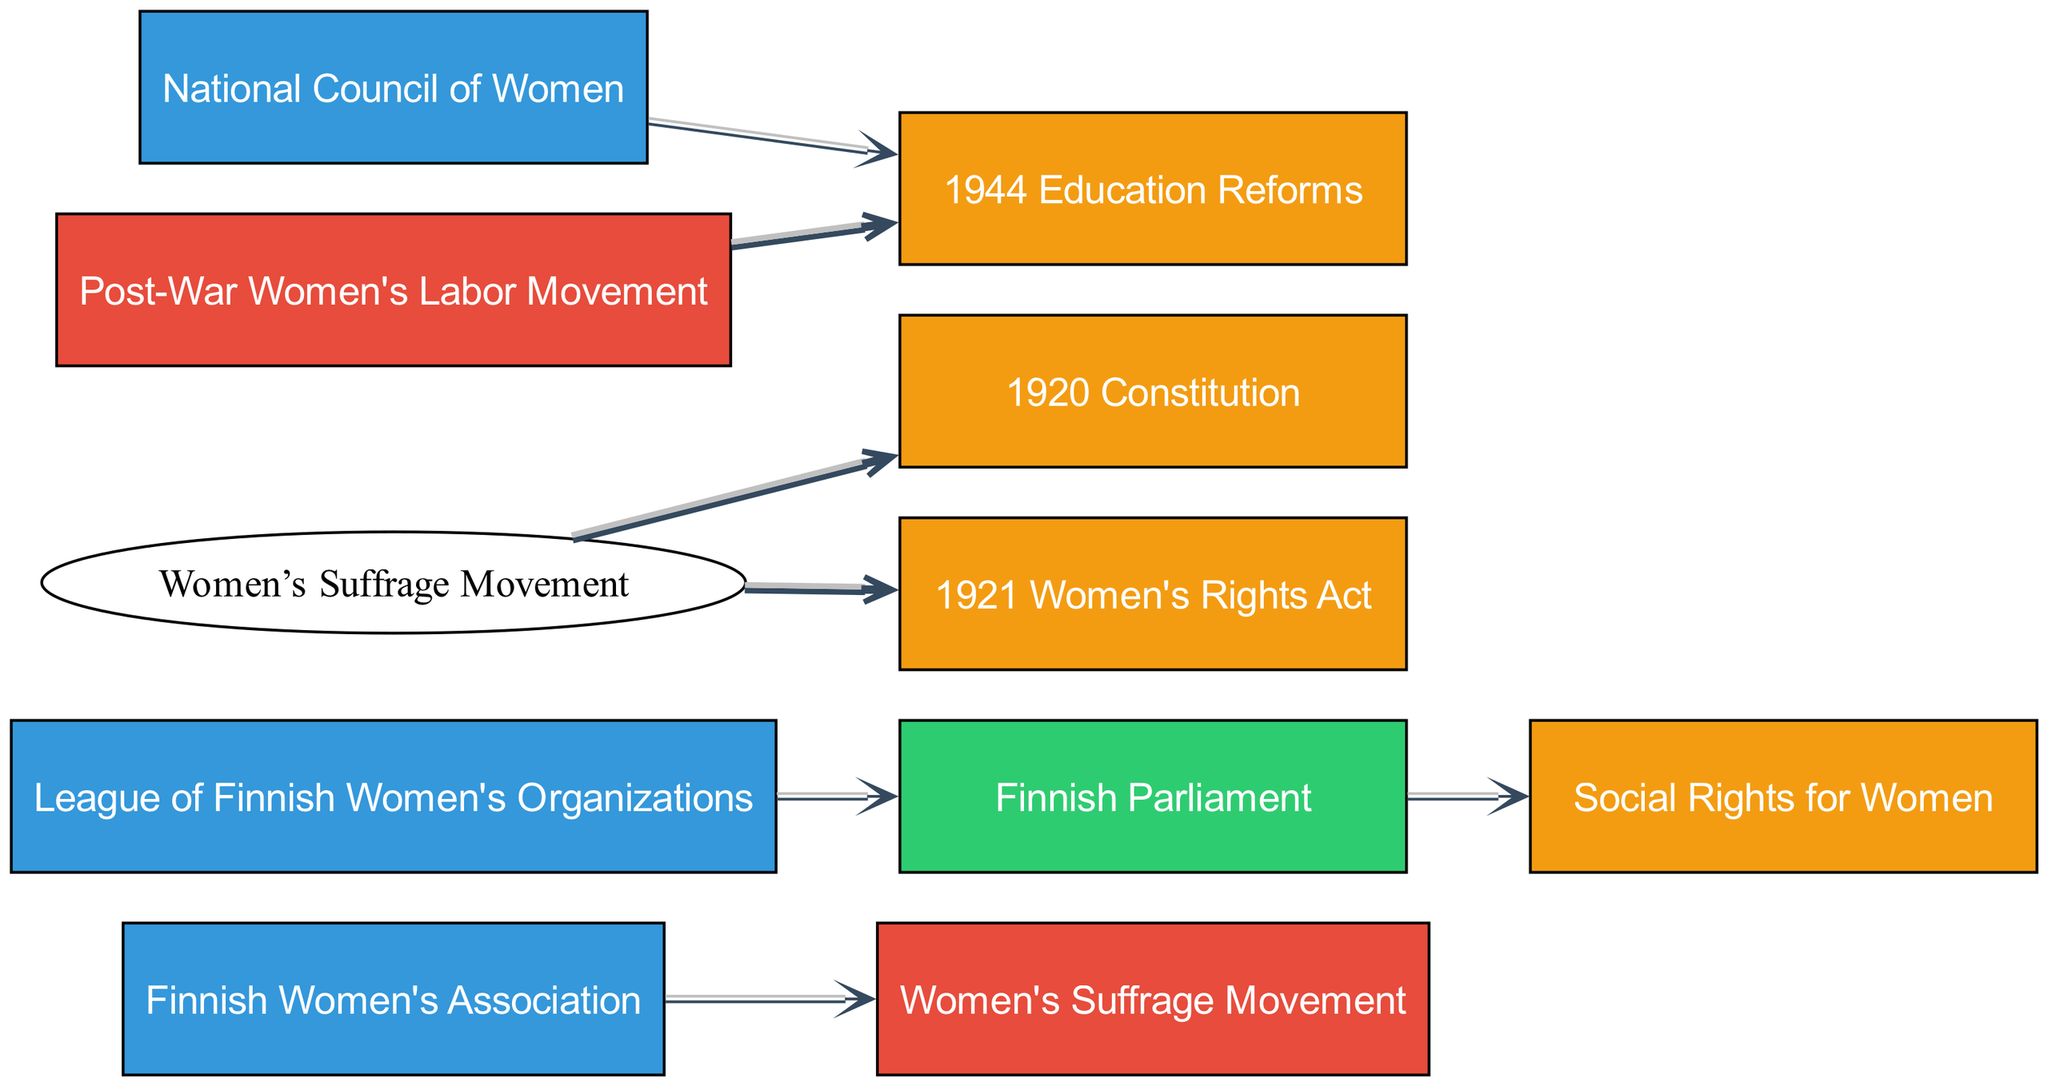What organizations are connected to the Women's Suffrage Movement? By examining the links in the diagram, we can see that the "Finnish Women's Association" is connected to the "Women's Suffrage Movement." Thus, there is one direct connection from the organization to this movement.
Answer: Finnish Women's Association How many events are linked from the Women's Suffrage Movement? The diagram shows two connections originating from the "Women's Suffrage Movement," which lead to the "1920 Constitution" and the "1921 Women's Rights Act." Therefore, there are two events linked from the movement.
Answer: 2 What institution is connected to the League of Finnish Women's Organizations? Following the links, we can see that the "League of Finnish Women's Organizations" has a direct connection to the "Finnish Parliament." Thus, the institution connected to this organization is the Finnish Parliament.
Answer: Finnish Parliament Which movement connects to the 1944 Education Reforms? The diagram indicates that both the "National Council of Women" and the "Post-War Women's Labor Movement" are connected to the "1944 Education Reforms." This means that there are two movements, but the question is asking for one. I can highlight one movement, and it would be "Post-War Women's Labor Movement."
Answer: Post-War Women's Labor Movement What is the value of the link from the Women's Suffrage Movement to the 1921 Women's Rights Act? The directed edge in the diagram shows the "Women's Suffrage Movement" linked to the "1921 Women's Rights Act" with a value of 2. Hence, the value of this link is two.
Answer: 2 How many nodes represent organizations in total? By counting the nodes labeled as organizations in the diagram, we find that there are three organizations: "Finnish Women's Association," "League of Finnish Women's Organizations," and "National Council of Women." Therefore, the total number of organization nodes is three.
Answer: 3 Which event has the highest number of connections? By evaluating the total links outgoing from each event node, "1944 Education Reforms" has two incoming connections (from the "National Council of Women" and "Post-War Women's Labor Movement"), outperforming the others, which have fewer or are isolated. Thus, it has the highest number of connections.
Answer: 1944 Education Reforms What is the relationship between Women’s Suffrage Movement and Social Rights for Women? The diagram does not depict a direct link between the "Women’s Suffrage Movement" and "Social Rights for Women." The only connection is through the "Finnish Parliament," which implies an indirect relationship. Thus, there is no direct relationship evident in this diagram.
Answer: None 